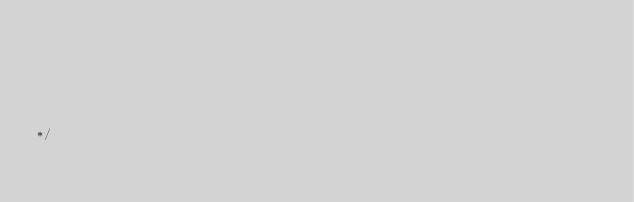Convert code to text. <code><loc_0><loc_0><loc_500><loc_500><_JavaScript_>                                                                                                                                                                                                       
                                                                                                                                                                                                       
                                                                                                                                                                                                       
                                                                                                                                                                                                       
                                                                                                                                                                                                       
                                                                                                                                                                                                       

*/</code> 